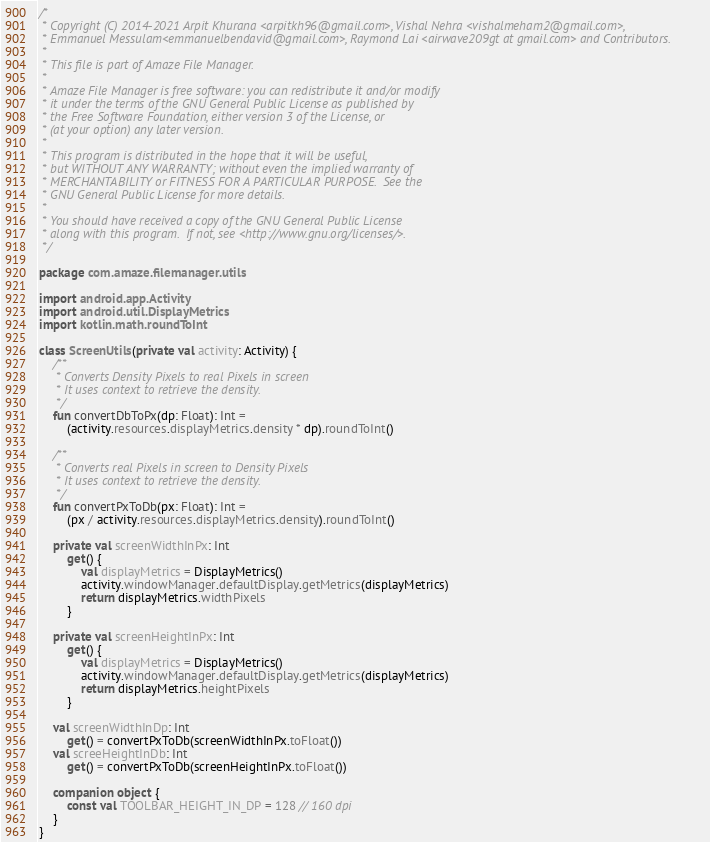Convert code to text. <code><loc_0><loc_0><loc_500><loc_500><_Kotlin_>/*
 * Copyright (C) 2014-2021 Arpit Khurana <arpitkh96@gmail.com>, Vishal Nehra <vishalmeham2@gmail.com>,
 * Emmanuel Messulam<emmanuelbendavid@gmail.com>, Raymond Lai <airwave209gt at gmail.com> and Contributors.
 *
 * This file is part of Amaze File Manager.
 *
 * Amaze File Manager is free software: you can redistribute it and/or modify
 * it under the terms of the GNU General Public License as published by
 * the Free Software Foundation, either version 3 of the License, or
 * (at your option) any later version.
 *
 * This program is distributed in the hope that it will be useful,
 * but WITHOUT ANY WARRANTY; without even the implied warranty of
 * MERCHANTABILITY or FITNESS FOR A PARTICULAR PURPOSE.  See the
 * GNU General Public License for more details.
 *
 * You should have received a copy of the GNU General Public License
 * along with this program.  If not, see <http://www.gnu.org/licenses/>.
 */

package com.amaze.filemanager.utils

import android.app.Activity
import android.util.DisplayMetrics
import kotlin.math.roundToInt

class ScreenUtils(private val activity: Activity) {
    /**
     * Converts Density Pixels to real Pixels in screen
     * It uses context to retrieve the density.
     */
    fun convertDbToPx(dp: Float): Int =
        (activity.resources.displayMetrics.density * dp).roundToInt()

    /**
     * Converts real Pixels in screen to Density Pixels
     * It uses context to retrieve the density.
     */
    fun convertPxToDb(px: Float): Int =
        (px / activity.resources.displayMetrics.density).roundToInt()

    private val screenWidthInPx: Int
        get() {
            val displayMetrics = DisplayMetrics()
            activity.windowManager.defaultDisplay.getMetrics(displayMetrics)
            return displayMetrics.widthPixels
        }

    private val screenHeightInPx: Int
        get() {
            val displayMetrics = DisplayMetrics()
            activity.windowManager.defaultDisplay.getMetrics(displayMetrics)
            return displayMetrics.heightPixels
        }

    val screenWidthInDp: Int
        get() = convertPxToDb(screenWidthInPx.toFloat())
    val screeHeightInDb: Int
        get() = convertPxToDb(screenHeightInPx.toFloat())

    companion object {
        const val TOOLBAR_HEIGHT_IN_DP = 128 // 160 dpi
    }
}
</code> 